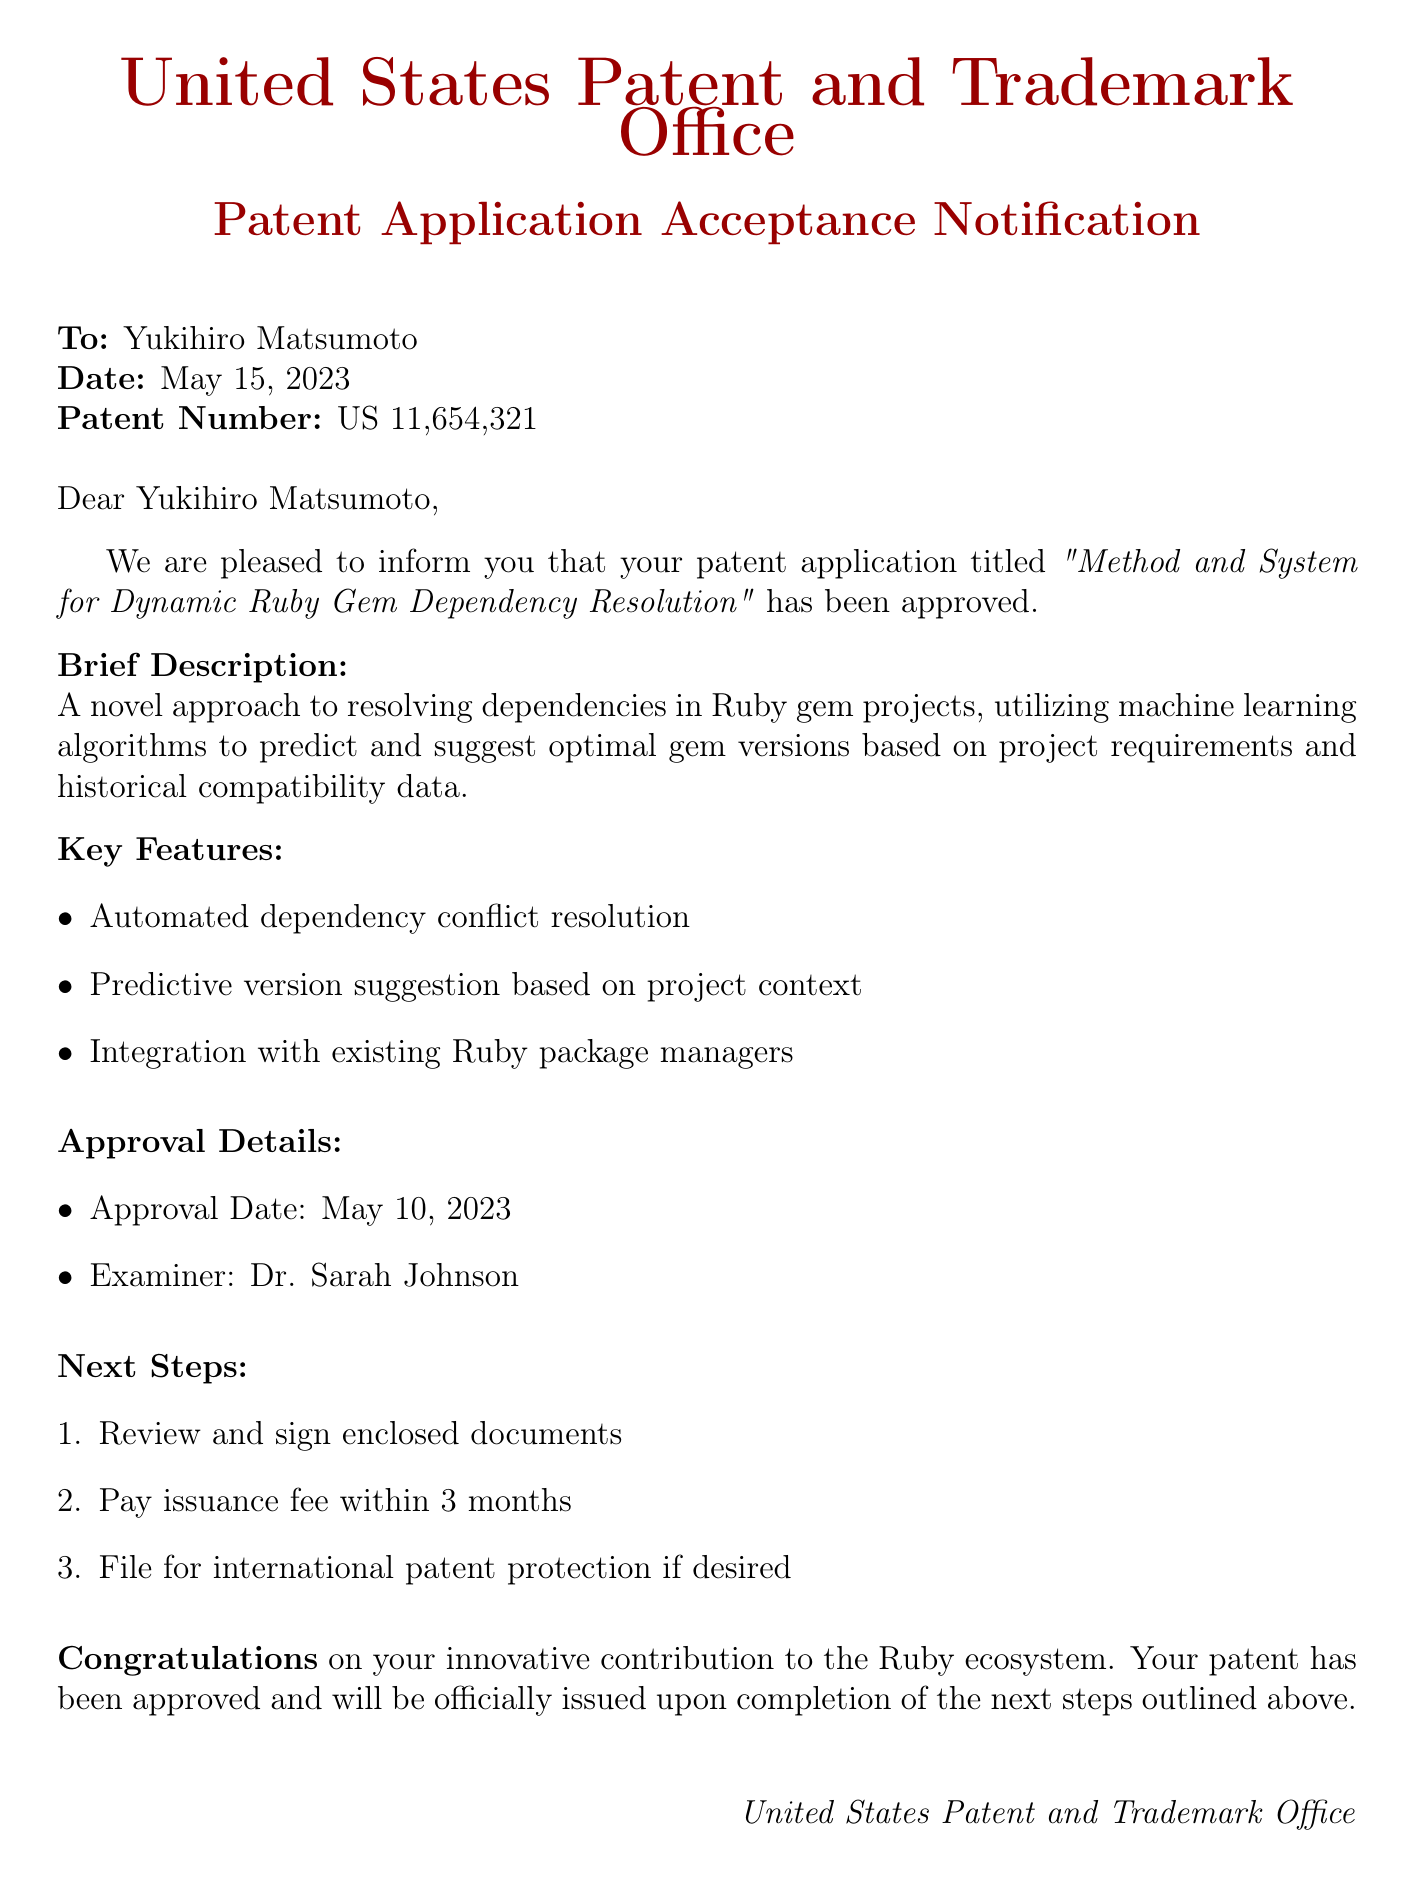What is the name of the patent? The name of the patent is provided in the document as "Method and System for Dynamic Ruby Gem Dependency Resolution."
Answer: Method and System for Dynamic Ruby Gem Dependency Resolution Who is the applicant of the patent? The document specifies the applicant as Yukihiro Matsumoto.
Answer: Yukihiro Matsumoto What is the patent number? The patent number is clearly stated in the document, which is US 11,654,321.
Answer: US 11,654,321 When was the patent application accepted? The acceptance date is listed in the details section, which is May 10, 2023.
Answer: May 10, 2023 What are two key features of the patented innovation? The document lists several features, including automated dependency conflict resolution and predictive version suggestion.
Answer: Automated dependency conflict resolution, predictive version suggestion Who was the examiner for the patent application? The examiner's name is mentioned in the document, which is Dr. Sarah Johnson.
Answer: Dr. Sarah Johnson What is the next step regarding the issuance fee? The document states that the issuance fee must be paid within 3 months.
Answer: Within 3 months What technology does the patent utilize? The document describes the innovation as utilizing machine learning algorithms for dependency resolution.
Answer: Machine learning algorithms What date was the patent acceptance notification issued? The issued date of the notification is explicitly mentioned as May 15, 2023.
Answer: May 15, 2023 